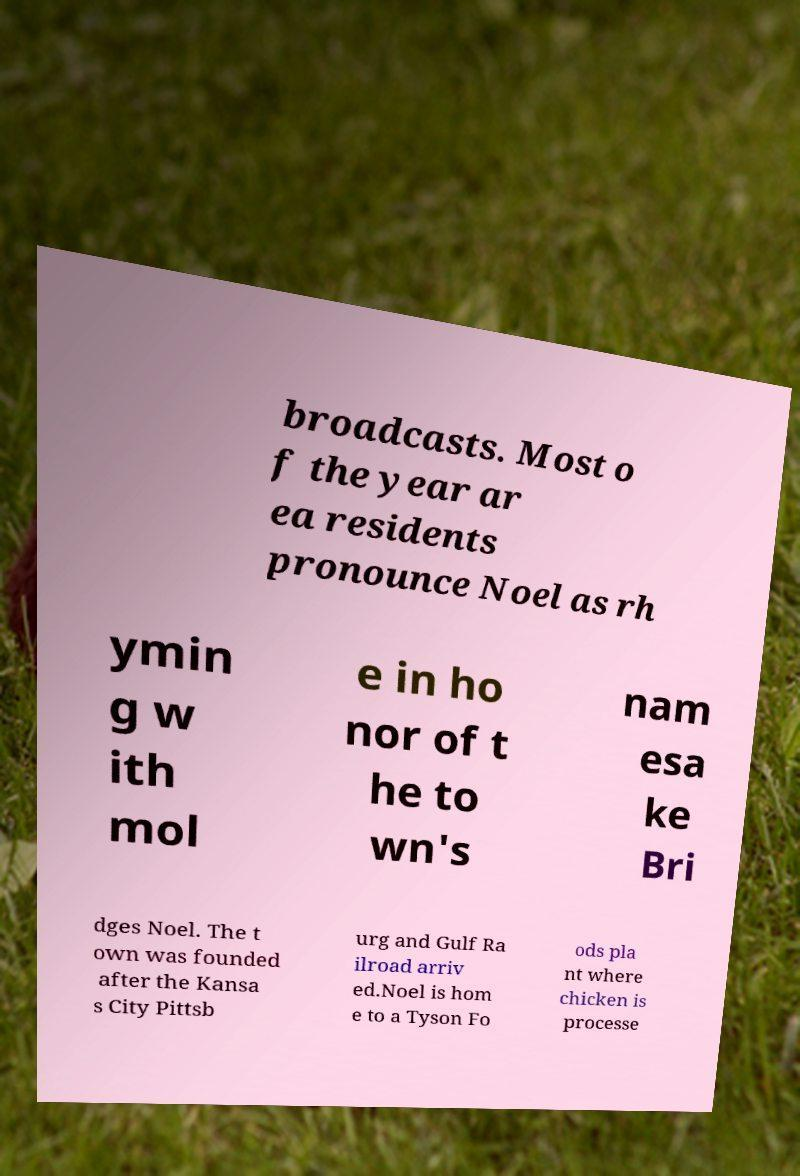There's text embedded in this image that I need extracted. Can you transcribe it verbatim? broadcasts. Most o f the year ar ea residents pronounce Noel as rh ymin g w ith mol e in ho nor of t he to wn's nam esa ke Bri dges Noel. The t own was founded after the Kansa s City Pittsb urg and Gulf Ra ilroad arriv ed.Noel is hom e to a Tyson Fo ods pla nt where chicken is processe 